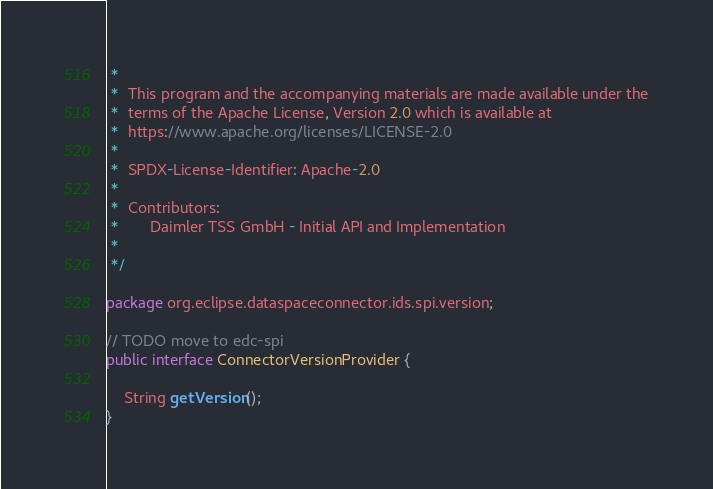Convert code to text. <code><loc_0><loc_0><loc_500><loc_500><_Java_> *
 *  This program and the accompanying materials are made available under the
 *  terms of the Apache License, Version 2.0 which is available at
 *  https://www.apache.org/licenses/LICENSE-2.0
 *
 *  SPDX-License-Identifier: Apache-2.0
 *
 *  Contributors:
 *       Daimler TSS GmbH - Initial API and Implementation
 *
 */

package org.eclipse.dataspaceconnector.ids.spi.version;

// TODO move to edc-spi
public interface ConnectorVersionProvider {

    String getVersion();
}
</code> 